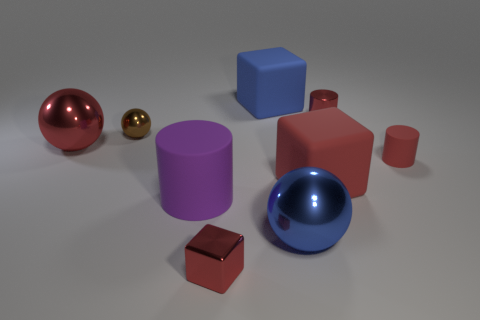What number of things are small green rubber things or red things?
Make the answer very short. 5. How many purple rubber objects are the same shape as the blue matte object?
Provide a short and direct response. 0. Do the small red cube and the big red thing that is left of the big purple cylinder have the same material?
Your answer should be very brief. Yes. What size is the other cube that is the same material as the big red block?
Make the answer very short. Large. There is a red metal thing that is on the right side of the shiny cube; what size is it?
Give a very brief answer. Small. How many objects are the same size as the red shiny block?
Offer a terse response. 3. What size is the shiny block that is the same color as the small matte object?
Your answer should be compact. Small. Is there a ball that has the same color as the metal cylinder?
Provide a succinct answer. Yes. There is a cube that is the same size as the shiny cylinder; what is its color?
Keep it short and to the point. Red. There is a tiny rubber object; does it have the same color as the thing in front of the blue metallic sphere?
Provide a short and direct response. Yes. 